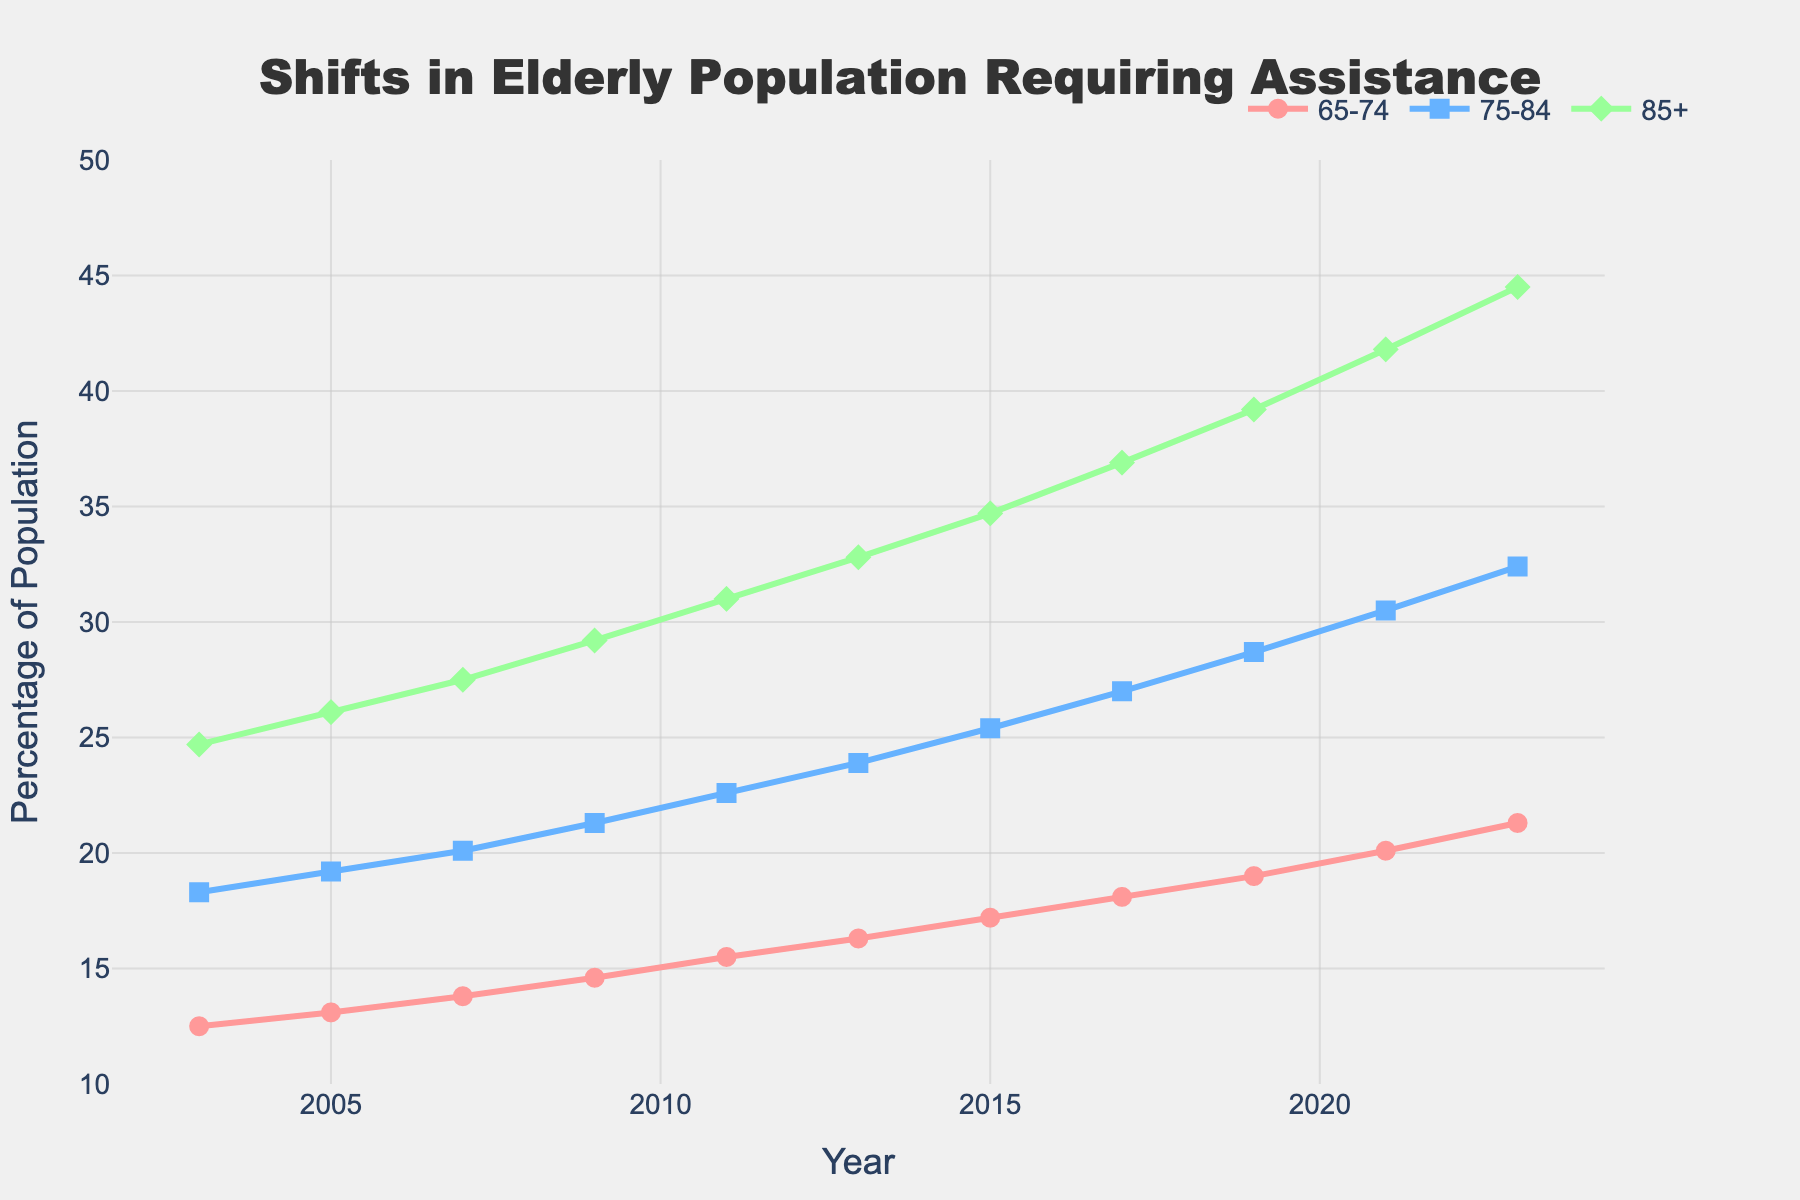What is the general trend of the elderly population requiring assistance for the age group 65-74 over the last 20 years? To determine the trend, we can observe the line representing the 65-74 age group. Starting from 12.5% in 2003, it gradually increases to 21.3% in 2023, indicating an upward trend.
Answer: Upward trend In which year does the 85+ age group surpass 30% for the first time? We need to look at the line representing the 85+ age group and pick the first year where the value exceeds 30%. This occurs in 2011 with a value of 31.0%.
Answer: 2011 Which age group shows the highest percentage increase from 2003 to 2023? First, calculate the percentage increase for each age group using the formula: ((final value - initial value) / initial value) * 100. The 65-74 group increases by ((21.3 - 12.5) / 12.5) * 100 = 70.4%, the 75-84 group by ((32.4 - 18.3) / 18.3) * 100 = 77.0%, and the 85+ group by ((44.5 - 24.7) / 24.7) * 100 = 80.2%. The 85+ group has the highest increase.
Answer: 85+ What is the difference in the percentage of elderly requiring assistance between the ages 75-84 and 85+ in 2019? Find the percentages for both age groups in 2019 and subtract one from the other. The 75-84 group has 28.7%, and the 85+ group has 39.2%. The difference is 39.2 - 28.7 = 10.5%.
Answer: 10.5% Between which two consecutive years did the 75-84 age group experience the largest increase in percentage? Observe the percentage changes year by year for the 75-84 age group. The largest increase is from 2019 (28.7%) to 2021 (30.5%), with an increase of 30.5 - 28.7 = 1.8%.
Answer: 2019 to 2021 Does the 65-74 age group ever surpass 20% in the given timeframe? If so, in which year does this first occur? Check the values corresponding to the 65-74 age group line to find the first year it exceeds 20%. This happens in 2021 with a value of 20.1%.
Answer: 2021 How do the trends in the 75-84 and 85+ age groups compare from 2003 to 2023? Both age groups show an upward trend over the years. The 75-84 group increases from 18.3% to 32.4%, while the 85+ group increases from 24.7% to 44.5%. Both trends depict a steady rise, with the 85+ group having a steeper slope.
Answer: Both trends are upward What is the average percentage of the 85+ age group requiring assistance over the 20 years? Sum all the yearly values for the 85+ group and divide by the number of years (11 values). (24.7 + 26.1 + 27.5 + 29.2 + 31.0 + 32.8 + 34.7 + 36.9 + 39.2 + 41.8 + 44.5) / 11 ≈ 33.1%.
Answer: 33.1% In 2023, which age group has the lowest percentage of elderly requiring assistance? Compare the values in 2023 for all age groups. The 65-74 group has 21.3%, the 75-84 group has 32.4%, and the 85+ group has 44.5%. The 65-74 group has the lowest percentage.
Answer: 65-74 By how much did the percentage of the 75-84 age group requiring assistance increase from 2011 to 2015? Check the percentages for 2011 and 2015, then subtract the earlier value from the later value. The 75-84 group was at 22.6% in 2011 and 25.4% in 2015, so the increase is 25.4 - 22.6 = 2.8%.
Answer: 2.8% 